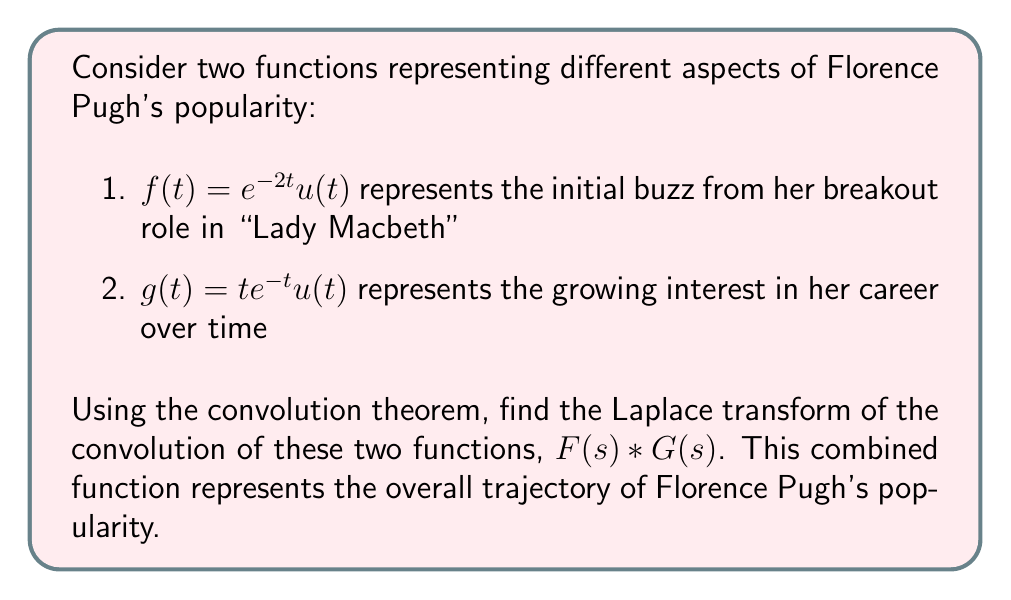Provide a solution to this math problem. Let's approach this step-by-step:

1) First, we need to find the Laplace transforms of $f(t)$ and $g(t)$:

   For $f(t) = e^{-2t}u(t)$:
   $$F(s) = \mathcal{L}\{e^{-2t}u(t)\} = \frac{1}{s+2}$$

   For $g(t) = te^{-t}u(t)$:
   $$G(s) = \mathcal{L}\{te^{-t}u(t)\} = \frac{1}{(s+1)^2}$$

2) The convolution theorem states that the Laplace transform of the convolution of two functions is equal to the product of their individual Laplace transforms:

   $$\mathcal{L}\{f(t) * g(t)\} = F(s) \cdot G(s)$$

3) Therefore, we need to multiply $F(s)$ and $G(s)$:

   $$F(s) \cdot G(s) = \frac{1}{s+2} \cdot \frac{1}{(s+1)^2}$$

4) Simplify the expression:

   $$F(s) \cdot G(s) = \frac{1}{(s+2)(s+1)^2}$$

This is the Laplace transform of the convolution of $f(t)$ and $g(t)$, representing the combined effect of Florence Pugh's initial popularity boost and her growing career interest over time.
Answer: $\frac{1}{(s+2)(s+1)^2}$ 